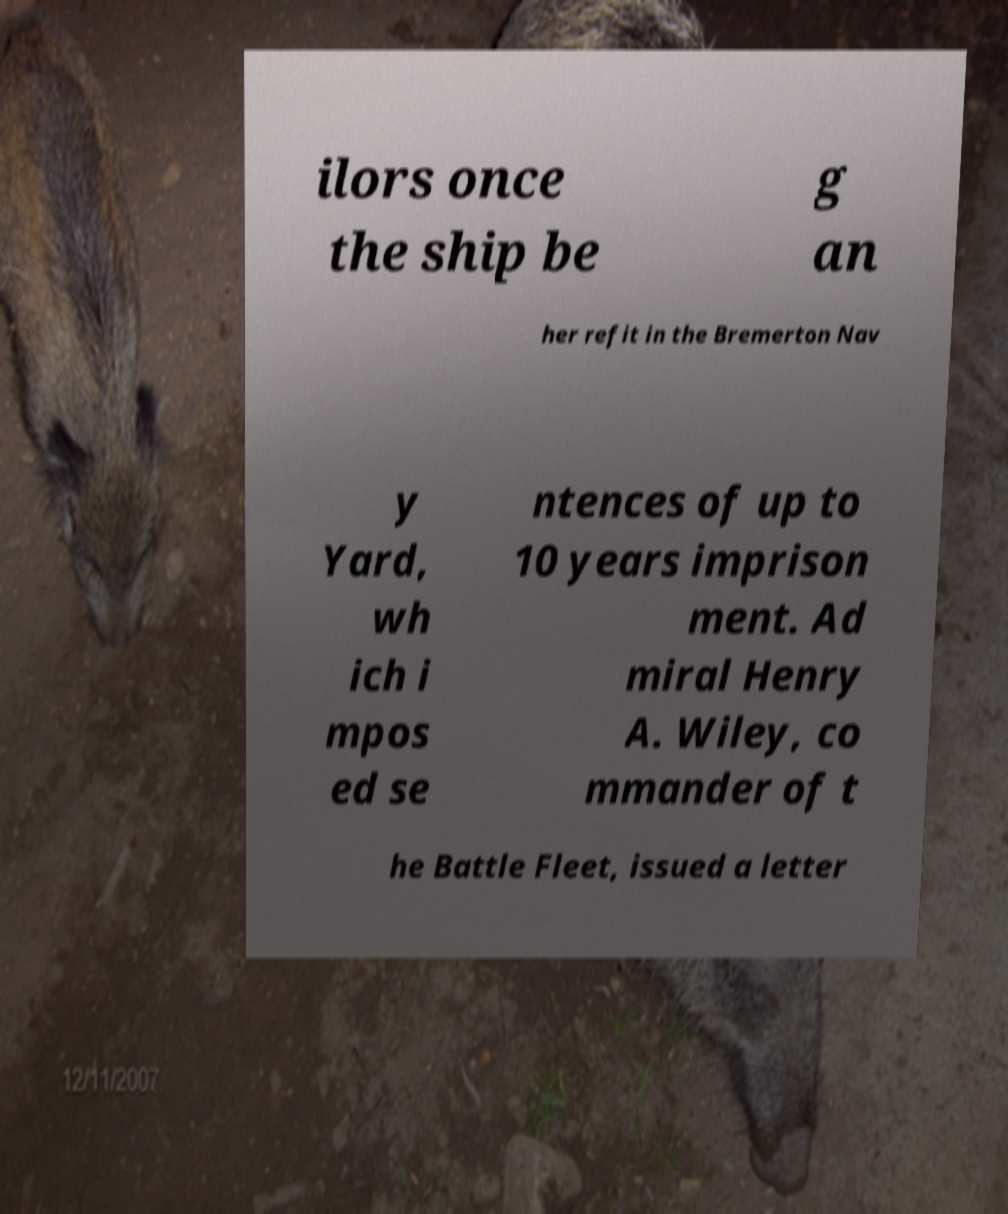I need the written content from this picture converted into text. Can you do that? ilors once the ship be g an her refit in the Bremerton Nav y Yard, wh ich i mpos ed se ntences of up to 10 years imprison ment. Ad miral Henry A. Wiley, co mmander of t he Battle Fleet, issued a letter 